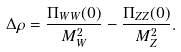Convert formula to latex. <formula><loc_0><loc_0><loc_500><loc_500>\Delta \rho = \frac { \Pi _ { W W } ( 0 ) } { M _ { W } ^ { 2 } } - \frac { \Pi _ { Z Z } ( 0 ) } { M _ { Z } ^ { 2 } } .</formula> 